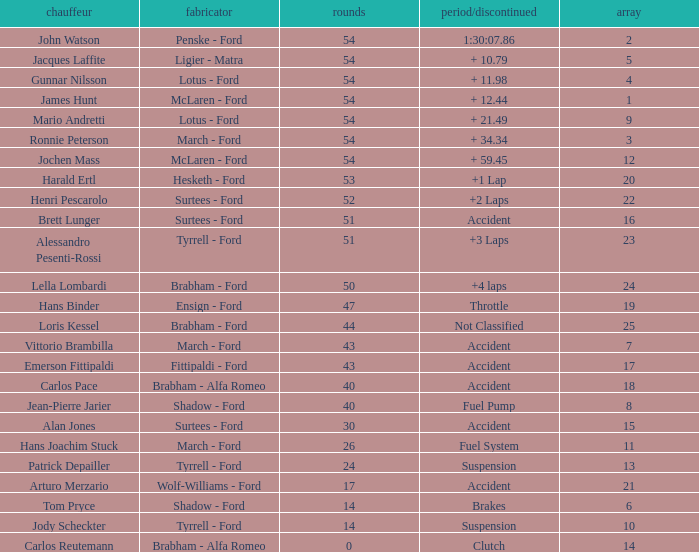What is the Time/Retired of Carlos Reutemann who was driving a brabham - Alfa Romeo? Clutch. 